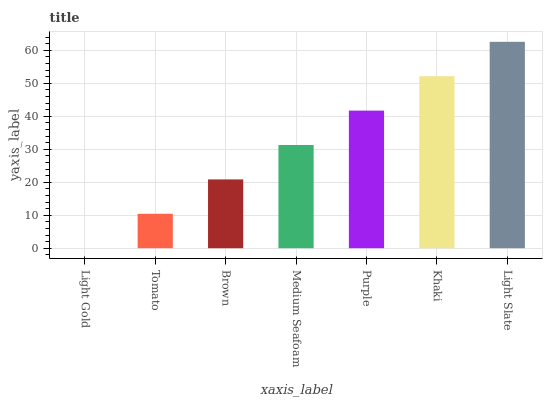Is Light Gold the minimum?
Answer yes or no. Yes. Is Light Slate the maximum?
Answer yes or no. Yes. Is Tomato the minimum?
Answer yes or no. No. Is Tomato the maximum?
Answer yes or no. No. Is Tomato greater than Light Gold?
Answer yes or no. Yes. Is Light Gold less than Tomato?
Answer yes or no. Yes. Is Light Gold greater than Tomato?
Answer yes or no. No. Is Tomato less than Light Gold?
Answer yes or no. No. Is Medium Seafoam the high median?
Answer yes or no. Yes. Is Medium Seafoam the low median?
Answer yes or no. Yes. Is Brown the high median?
Answer yes or no. No. Is Purple the low median?
Answer yes or no. No. 